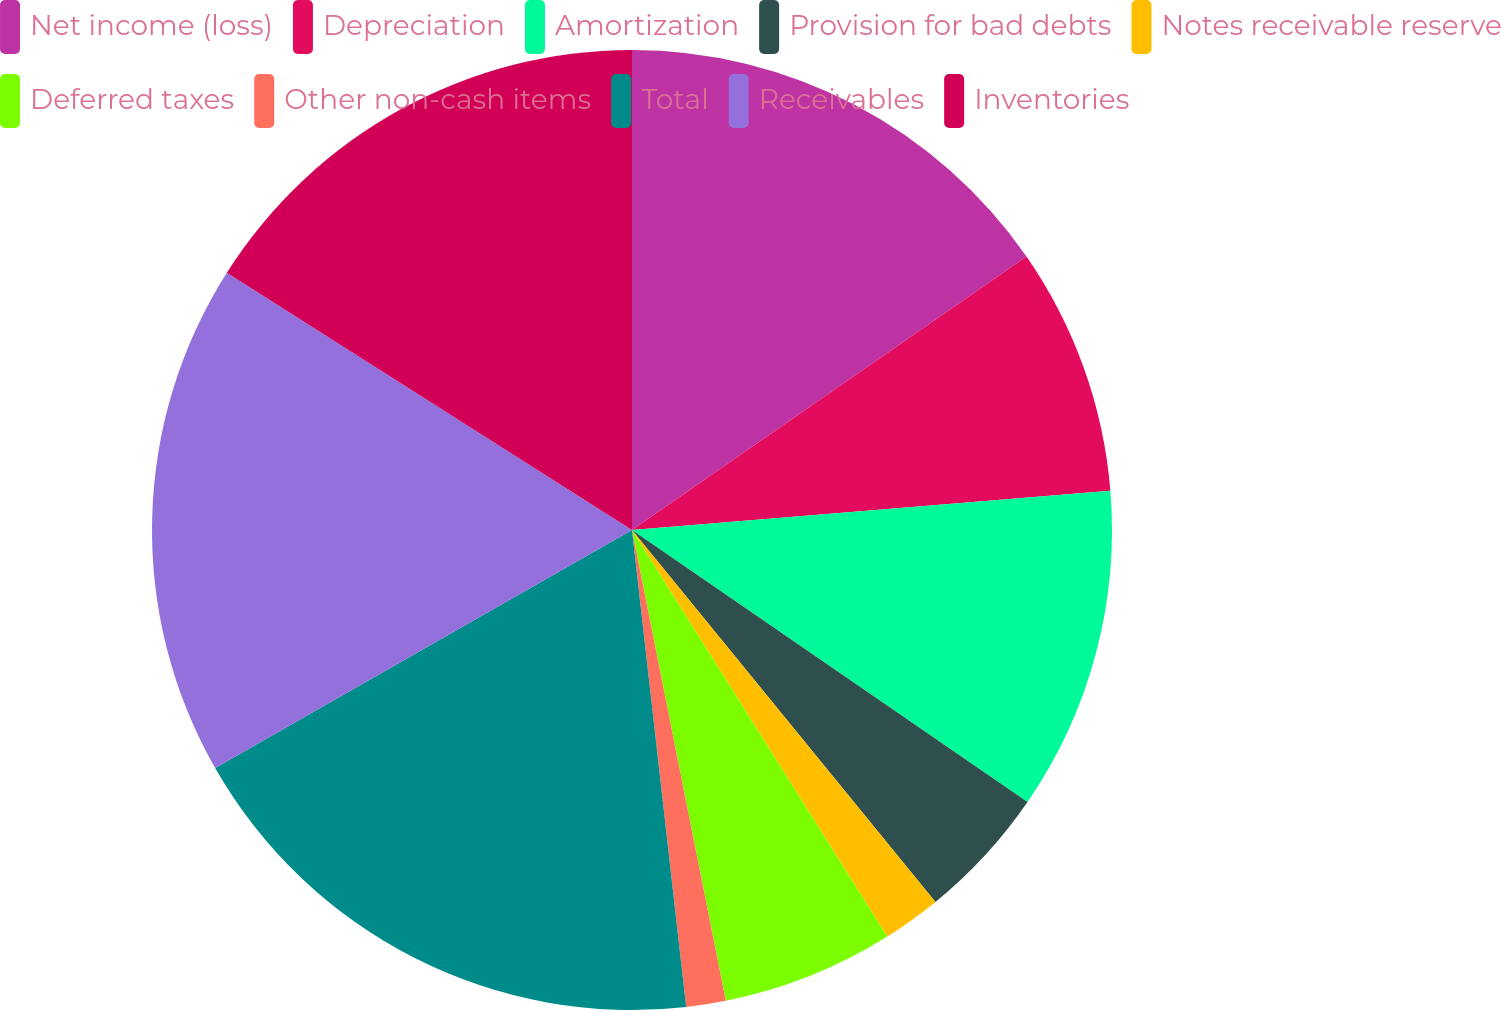Convert chart to OTSL. <chart><loc_0><loc_0><loc_500><loc_500><pie_chart><fcel>Net income (loss)<fcel>Depreciation<fcel>Amortization<fcel>Provision for bad debts<fcel>Notes receivable reserve<fcel>Deferred taxes<fcel>Other non-cash items<fcel>Total<fcel>Receivables<fcel>Inventories<nl><fcel>15.35%<fcel>8.34%<fcel>10.89%<fcel>4.52%<fcel>1.97%<fcel>5.79%<fcel>1.33%<fcel>18.54%<fcel>17.26%<fcel>15.99%<nl></chart> 